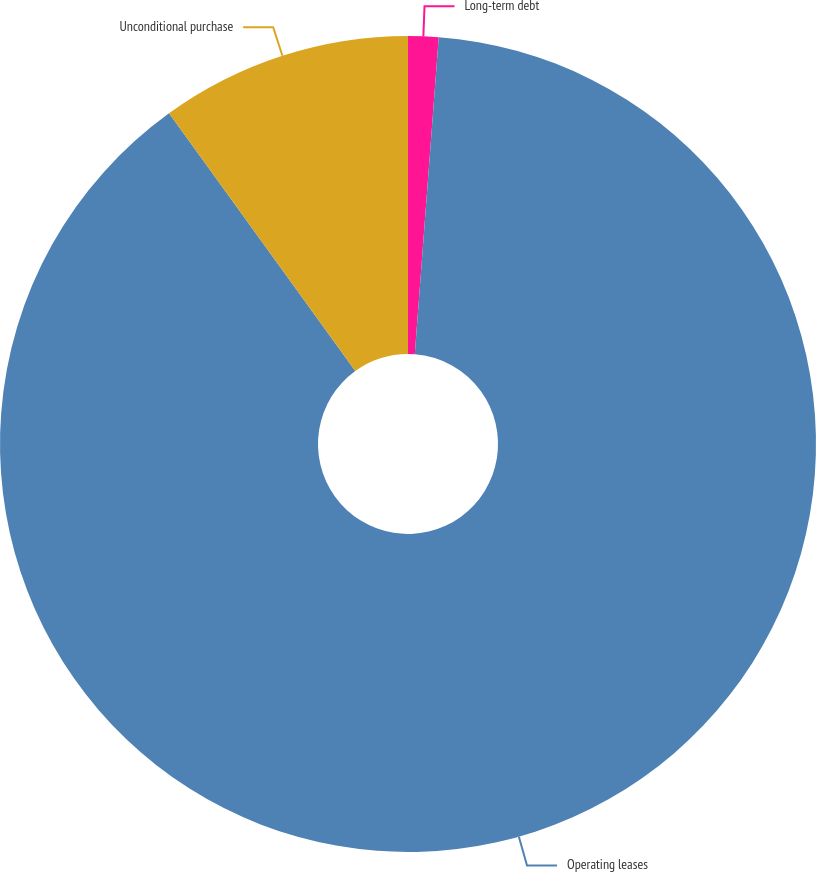Convert chart. <chart><loc_0><loc_0><loc_500><loc_500><pie_chart><fcel>Long-term debt<fcel>Operating leases<fcel>Unconditional purchase<nl><fcel>1.2%<fcel>88.84%<fcel>9.96%<nl></chart> 